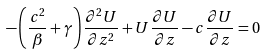Convert formula to latex. <formula><loc_0><loc_0><loc_500><loc_500>- \left ( \frac { c ^ { 2 } } { \beta } + \gamma \right ) \frac { { \partial } ^ { 2 } U } { \partial z ^ { 2 } } + U \frac { \partial U } { \partial z } - c \frac { \partial U } { \partial z } = 0</formula> 